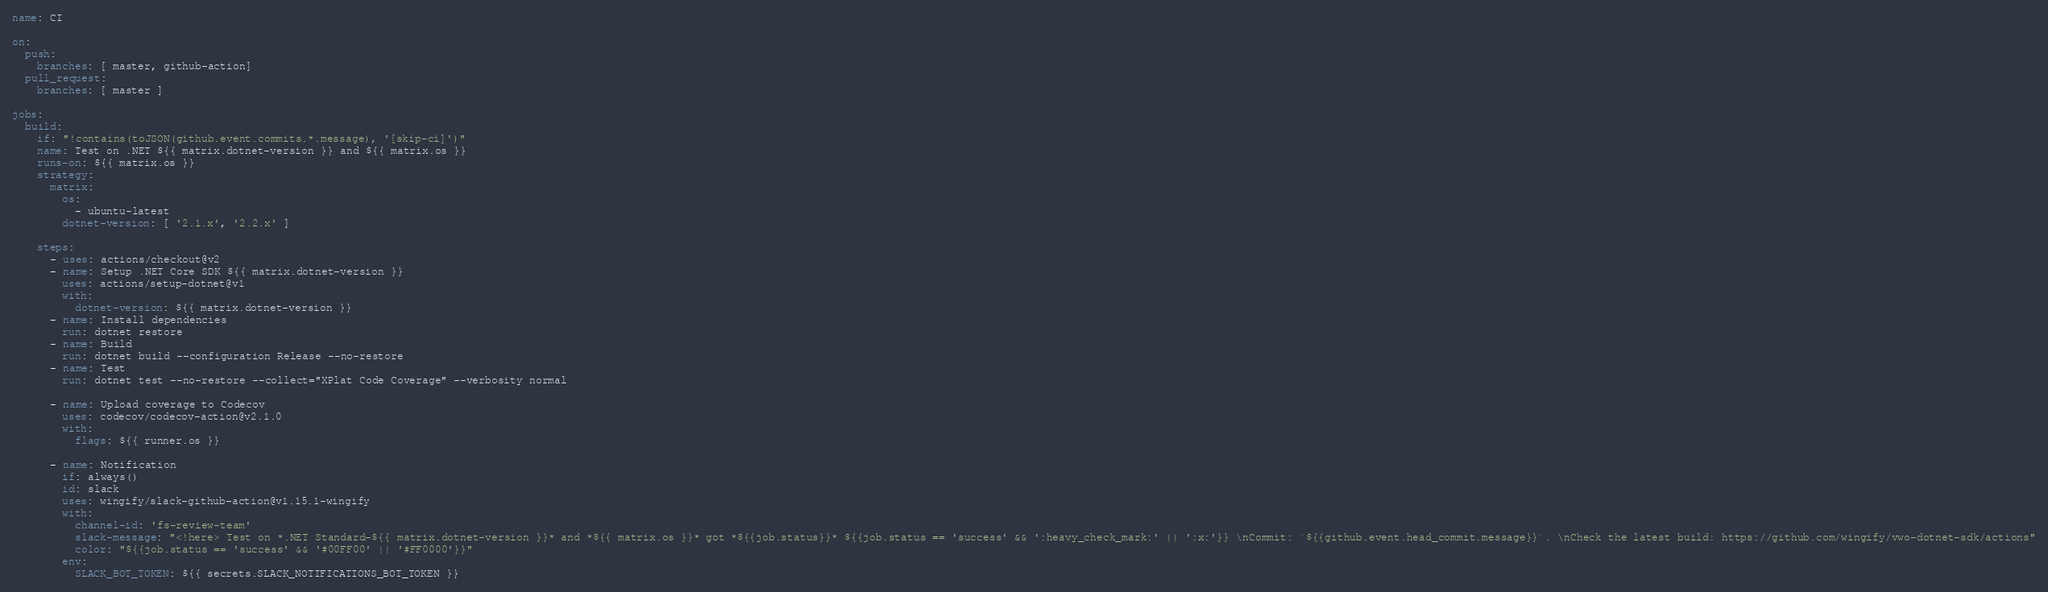Convert code to text. <code><loc_0><loc_0><loc_500><loc_500><_YAML_>name: CI

on:
  push:
    branches: [ master, github-action]
  pull_request:
    branches: [ master ]

jobs:
  build:
    if: "!contains(toJSON(github.event.commits.*.message), '[skip-ci]')"
    name: Test on .NET ${{ matrix.dotnet-version }} and ${{ matrix.os }}
    runs-on: ${{ matrix.os }}
    strategy:
      matrix:
        os:
          - ubuntu-latest
        dotnet-version: [ '2.1.x', '2.2.x' ]

    steps:
      - uses: actions/checkout@v2
      - name: Setup .NET Core SDK ${{ matrix.dotnet-version }}
        uses: actions/setup-dotnet@v1
        with:
          dotnet-version: ${{ matrix.dotnet-version }}
      - name: Install dependencies
        run: dotnet restore
      - name: Build
        run: dotnet build --configuration Release --no-restore
      - name: Test
        run: dotnet test --no-restore --collect="XPlat Code Coverage" --verbosity normal

      - name: Upload coverage to Codecov
        uses: codecov/codecov-action@v2.1.0
        with:
          flags: ${{ runner.os }}

      - name: Notification
        if: always()
        id: slack
        uses: wingify/slack-github-action@v1.15.1-wingify
        with:
          channel-id: 'fs-review-team'
          slack-message: "<!here> Test on *.NET Standard-${{ matrix.dotnet-version }}* and *${{ matrix.os }}* got *${{job.status}}* ${{job.status == 'success' && ':heavy_check_mark:' || ':x:'}} \nCommit: `${{github.event.head_commit.message}}`. \nCheck the latest build: https://github.com/wingify/vwo-dotnet-sdk/actions"
          color: "${{job.status == 'success' && '#00FF00' || '#FF0000'}}"
        env:
          SLACK_BOT_TOKEN: ${{ secrets.SLACK_NOTIFICATIONS_BOT_TOKEN }}
</code> 